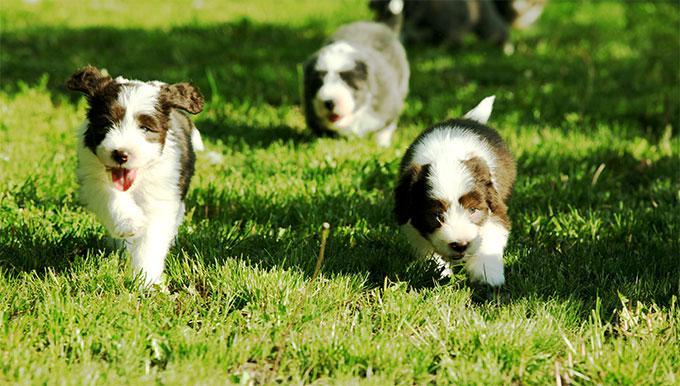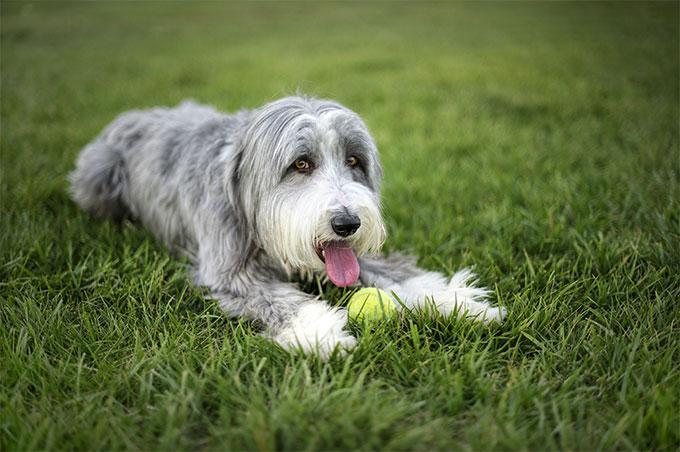The first image is the image on the left, the second image is the image on the right. Assess this claim about the two images: "An image shows one dog posed in the grass with a yellow ball.". Correct or not? Answer yes or no. Yes. The first image is the image on the left, the second image is the image on the right. Assess this claim about the two images: "The left image shows a dog running through grass while holding a toy in its mouth". Correct or not? Answer yes or no. No. 